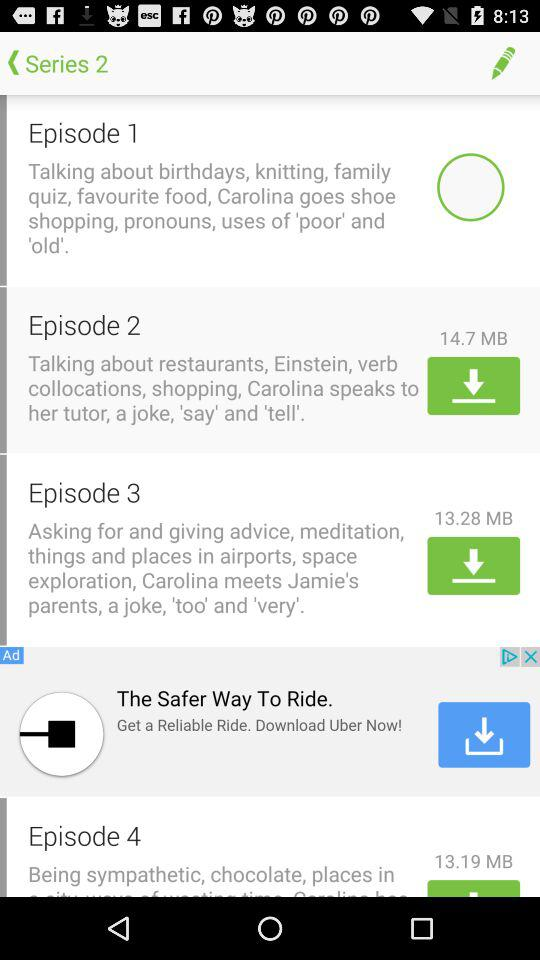What is the download size of the episode 4 file? The download size is 13.19 MB. 